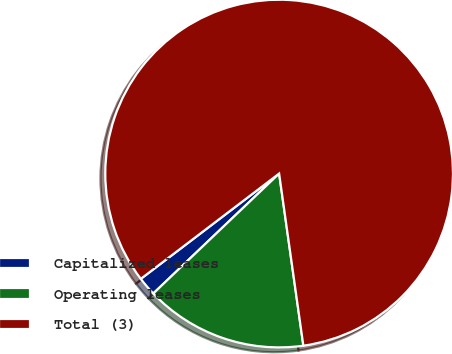<chart> <loc_0><loc_0><loc_500><loc_500><pie_chart><fcel>Capitalized leases<fcel>Operating leases<fcel>Total (3)<nl><fcel>1.76%<fcel>15.11%<fcel>83.13%<nl></chart> 